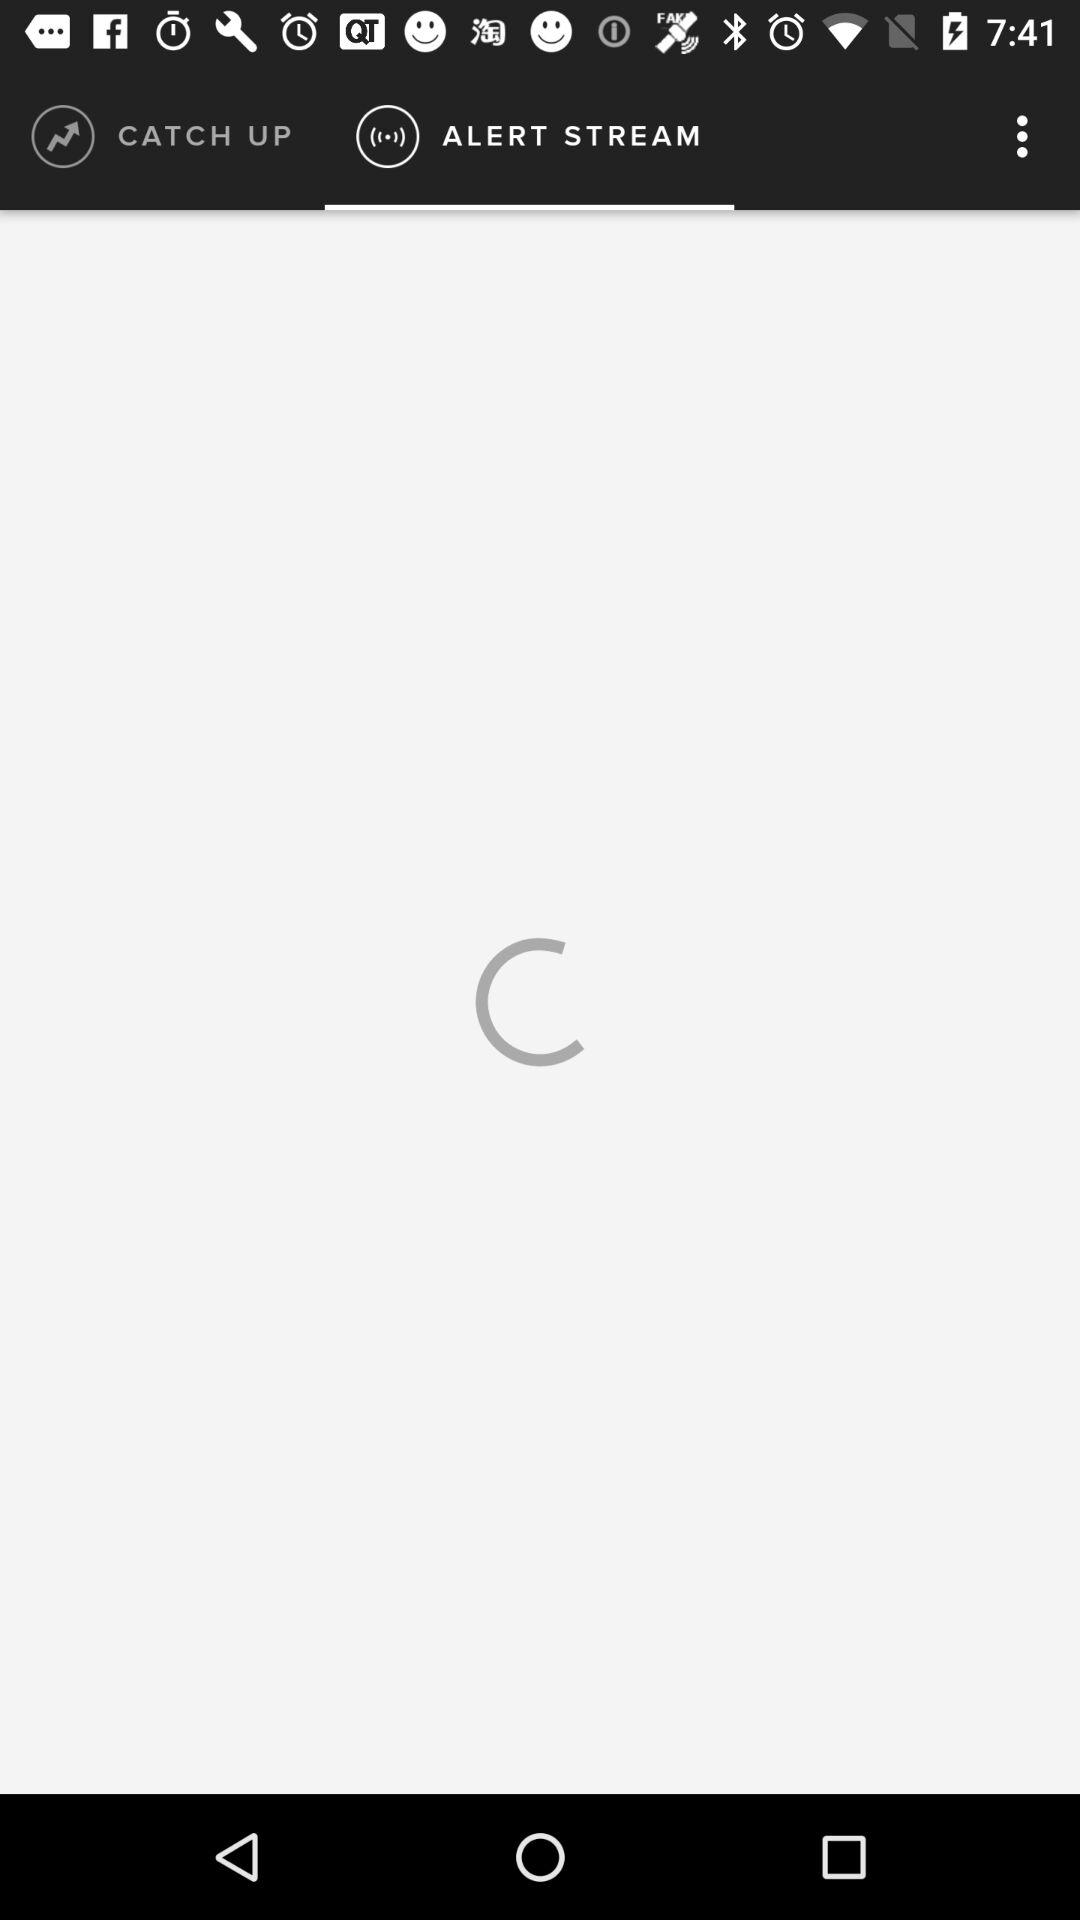Which tab has been selected? The tab that has been selected is "ALERT STREAM". 